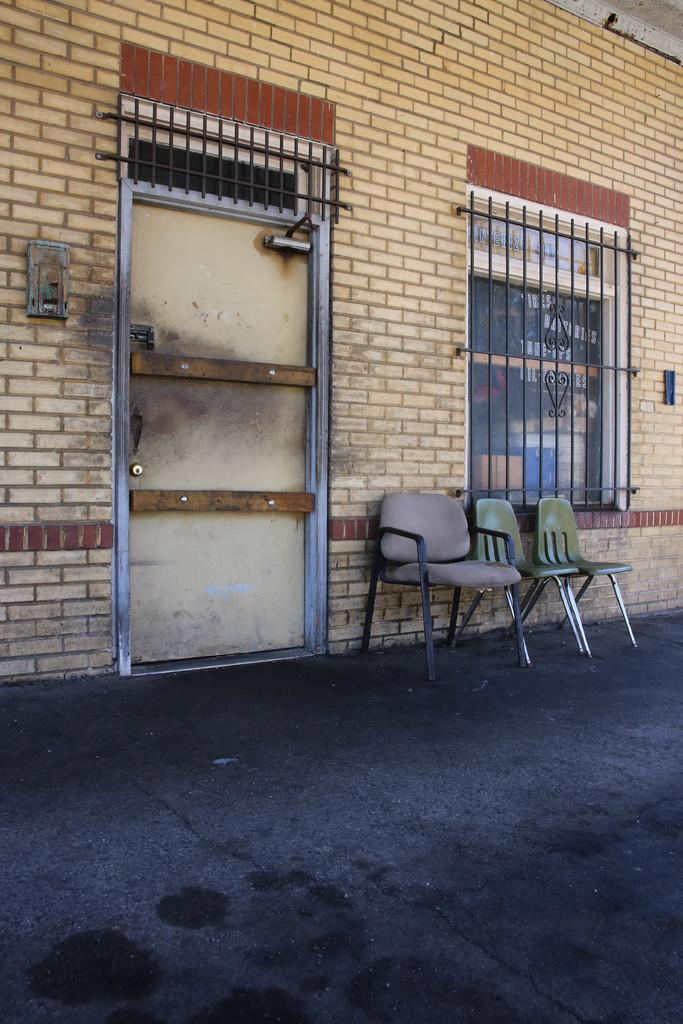How many chairs are in the image? There are three chairs in the image. Where are the chairs located? The chairs are on the floor. What is behind the chairs? There is a wall behind the chairs. What features can be seen on the wall? The wall has a door and a window. What type of invention is being demonstrated in the image? There is no invention being demonstrated in the image; it features three chairs on the floor with a wall behind them. Can you identify any prose written on the wall in the image? There is no prose visible on the wall in the image. 